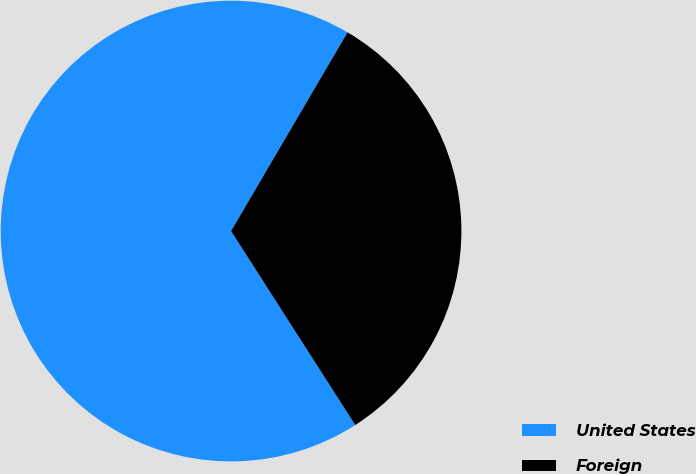<chart> <loc_0><loc_0><loc_500><loc_500><pie_chart><fcel>United States<fcel>Foreign<nl><fcel>67.5%<fcel>32.5%<nl></chart> 